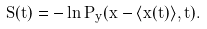<formula> <loc_0><loc_0><loc_500><loc_500>S ( t ) = - \ln P _ { y } ( x - \langle x ( t ) \rangle , t ) .</formula> 